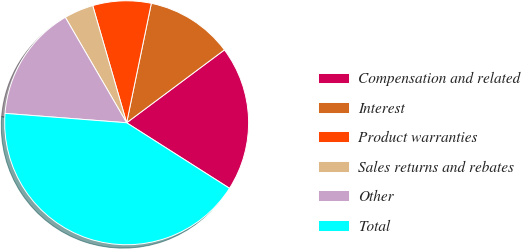Convert chart. <chart><loc_0><loc_0><loc_500><loc_500><pie_chart><fcel>Compensation and related<fcel>Interest<fcel>Product warranties<fcel>Sales returns and rebates<fcel>Other<fcel>Total<nl><fcel>19.22%<fcel>11.56%<fcel>7.73%<fcel>3.9%<fcel>15.39%<fcel>42.2%<nl></chart> 